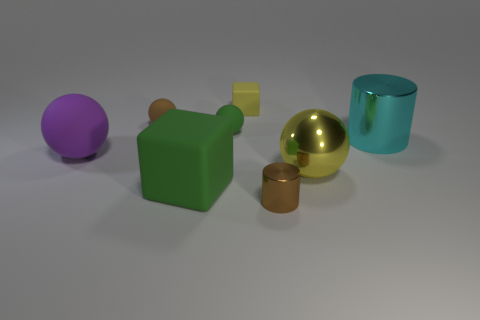What is the color of the small object right of the small cube?
Your answer should be compact. Brown. Are there any other things that are the same shape as the big cyan object?
Ensure brevity in your answer.  Yes. What is the size of the object in front of the block that is in front of the large cyan metal thing?
Offer a terse response. Small. Are there an equal number of small matte spheres that are to the right of the small brown matte ball and tiny blocks to the right of the small yellow cube?
Make the answer very short. No. Is there any other thing that has the same size as the green block?
Make the answer very short. Yes. What is the color of the other large object that is the same material as the large yellow thing?
Your answer should be compact. Cyan. Is the material of the large yellow object the same as the small ball in front of the small brown matte sphere?
Make the answer very short. No. The object that is both on the right side of the small brown metallic cylinder and behind the purple object is what color?
Offer a very short reply. Cyan. How many spheres are tiny gray things or large yellow metal objects?
Make the answer very short. 1. Does the large green matte thing have the same shape as the tiny rubber thing that is to the left of the small green thing?
Your response must be concise. No. 